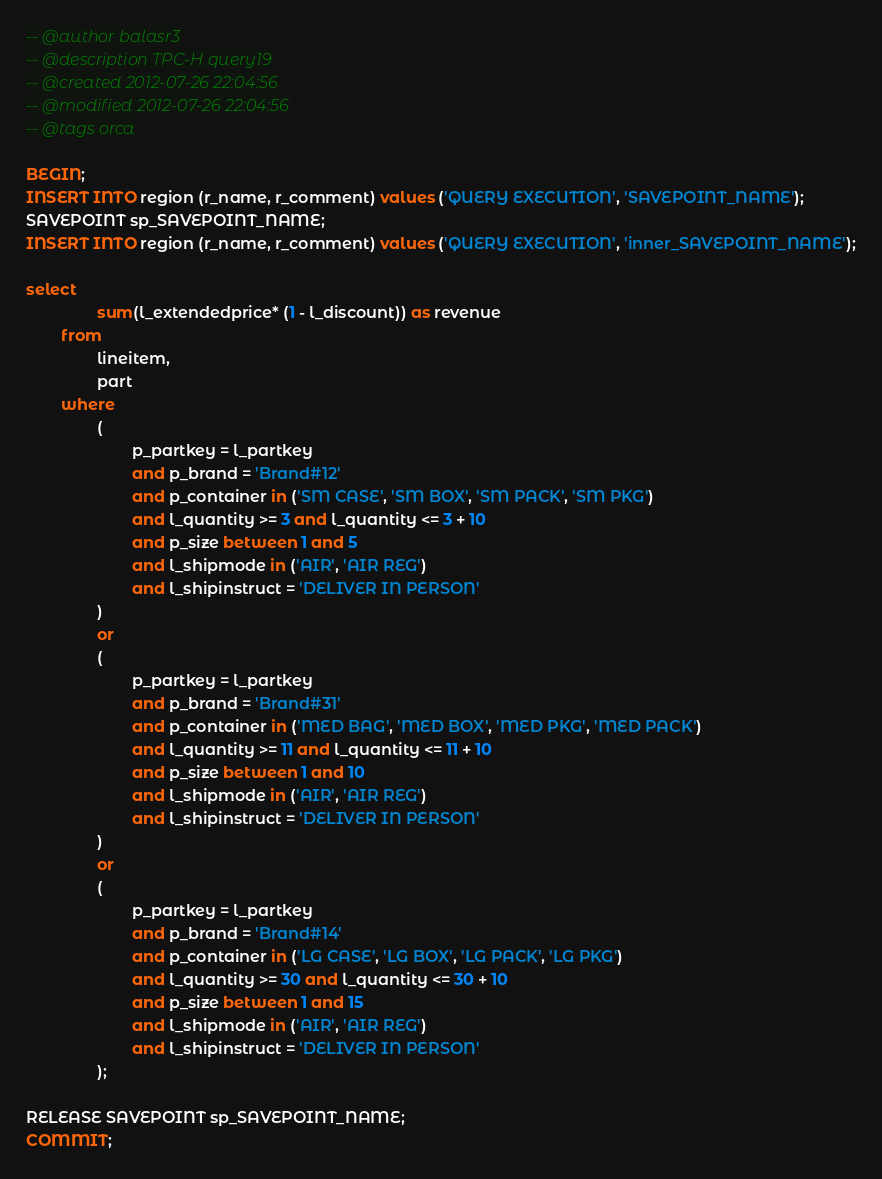<code> <loc_0><loc_0><loc_500><loc_500><_SQL_>-- @author balasr3
-- @description TPC-H query19
-- @created 2012-07-26 22:04:56
-- @modified 2012-07-26 22:04:56
-- @tags orca

BEGIN;
INSERT INTO region (r_name, r_comment) values ('QUERY EXECUTION', 'SAVEPOINT_NAME');
SAVEPOINT sp_SAVEPOINT_NAME;
INSERT INTO region (r_name, r_comment) values ('QUERY EXECUTION', 'inner_SAVEPOINT_NAME');

select
                sum(l_extendedprice* (1 - l_discount)) as revenue
        from
                lineitem,
                part
        where
                (
                        p_partkey = l_partkey
                        and p_brand = 'Brand#12'
                        and p_container in ('SM CASE', 'SM BOX', 'SM PACK', 'SM PKG')
                        and l_quantity >= 3 and l_quantity <= 3 + 10
                        and p_size between 1 and 5
                        and l_shipmode in ('AIR', 'AIR REG')
                        and l_shipinstruct = 'DELIVER IN PERSON'
                )
                or
                (
                        p_partkey = l_partkey
                        and p_brand = 'Brand#31'
                        and p_container in ('MED BAG', 'MED BOX', 'MED PKG', 'MED PACK')
                        and l_quantity >= 11 and l_quantity <= 11 + 10
                        and p_size between 1 and 10
                        and l_shipmode in ('AIR', 'AIR REG')
                        and l_shipinstruct = 'DELIVER IN PERSON'
                )
                or
                (
                        p_partkey = l_partkey
                        and p_brand = 'Brand#14'
                        and p_container in ('LG CASE', 'LG BOX', 'LG PACK', 'LG PKG')
                        and l_quantity >= 30 and l_quantity <= 30 + 10
                        and p_size between 1 and 15
                        and l_shipmode in ('AIR', 'AIR REG')
                        and l_shipinstruct = 'DELIVER IN PERSON'
                );

RELEASE SAVEPOINT sp_SAVEPOINT_NAME;
COMMIT;
</code> 